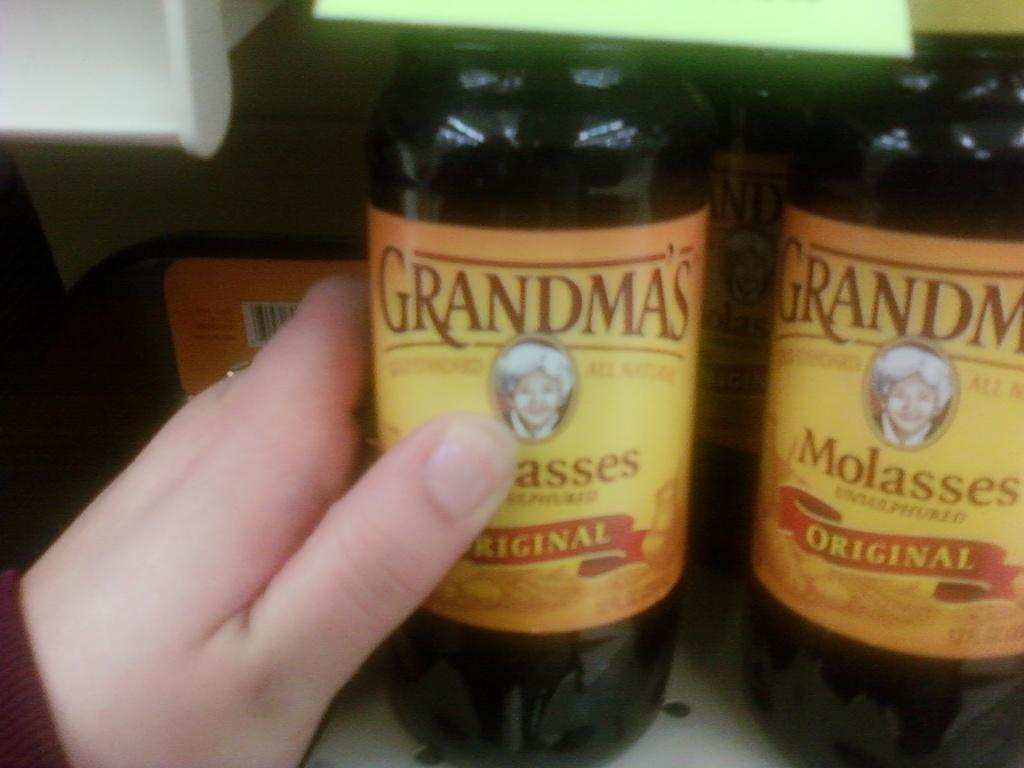<image>
Summarize the visual content of the image. A hand reaches for a bottle of Grandma's molasses. 